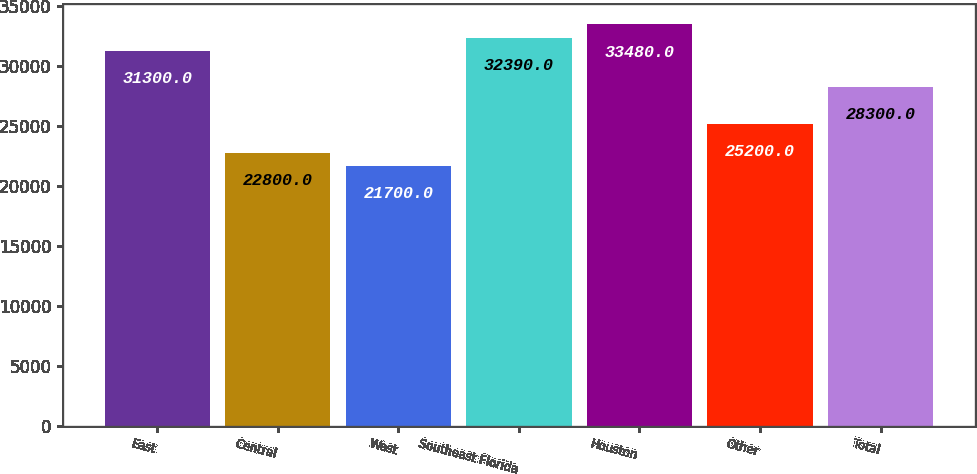Convert chart. <chart><loc_0><loc_0><loc_500><loc_500><bar_chart><fcel>East<fcel>Central<fcel>West<fcel>Southeast Florida<fcel>Houston<fcel>Other<fcel>Total<nl><fcel>31300<fcel>22800<fcel>21700<fcel>32390<fcel>33480<fcel>25200<fcel>28300<nl></chart> 